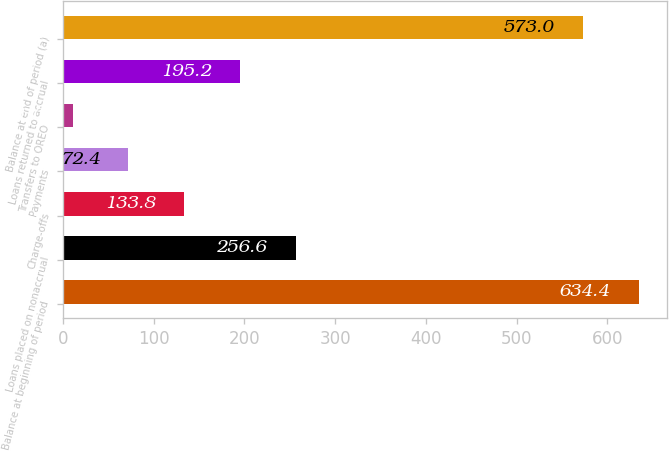Convert chart to OTSL. <chart><loc_0><loc_0><loc_500><loc_500><bar_chart><fcel>Balance at beginning of period<fcel>Loans placed on nonaccrual<fcel>Charge-offs<fcel>Payments<fcel>Transfers to OREO<fcel>Loans returned to accrual<fcel>Balance at end of period (a)<nl><fcel>634.4<fcel>256.6<fcel>133.8<fcel>72.4<fcel>11<fcel>195.2<fcel>573<nl></chart> 